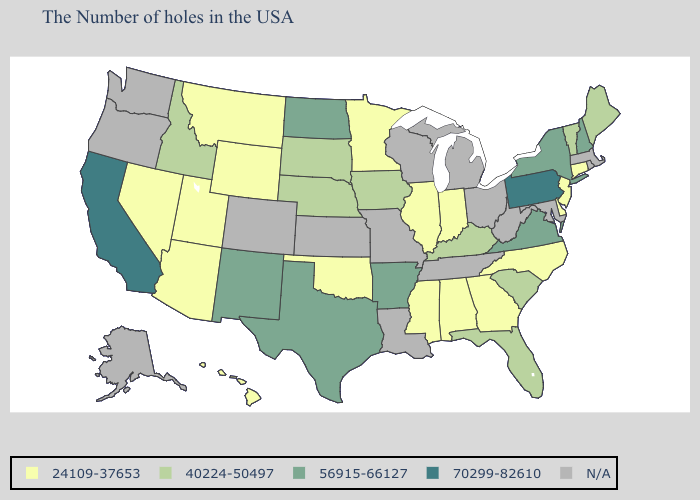What is the lowest value in the USA?
Quick response, please. 24109-37653. Name the states that have a value in the range 56915-66127?
Give a very brief answer. New Hampshire, New York, Virginia, Arkansas, Texas, North Dakota, New Mexico. Name the states that have a value in the range 56915-66127?
Concise answer only. New Hampshire, New York, Virginia, Arkansas, Texas, North Dakota, New Mexico. What is the value of Delaware?
Give a very brief answer. 24109-37653. Among the states that border Nebraska , does Wyoming have the lowest value?
Be succinct. Yes. What is the value of Maryland?
Concise answer only. N/A. What is the value of Iowa?
Keep it brief. 40224-50497. Does Virginia have the highest value in the South?
Be succinct. Yes. What is the value of Virginia?
Short answer required. 56915-66127. Name the states that have a value in the range 24109-37653?
Be succinct. Connecticut, New Jersey, Delaware, North Carolina, Georgia, Indiana, Alabama, Illinois, Mississippi, Minnesota, Oklahoma, Wyoming, Utah, Montana, Arizona, Nevada, Hawaii. Name the states that have a value in the range 24109-37653?
Be succinct. Connecticut, New Jersey, Delaware, North Carolina, Georgia, Indiana, Alabama, Illinois, Mississippi, Minnesota, Oklahoma, Wyoming, Utah, Montana, Arizona, Nevada, Hawaii. Name the states that have a value in the range 24109-37653?
Write a very short answer. Connecticut, New Jersey, Delaware, North Carolina, Georgia, Indiana, Alabama, Illinois, Mississippi, Minnesota, Oklahoma, Wyoming, Utah, Montana, Arizona, Nevada, Hawaii. Name the states that have a value in the range 40224-50497?
Short answer required. Maine, Vermont, South Carolina, Florida, Kentucky, Iowa, Nebraska, South Dakota, Idaho. Which states hav the highest value in the West?
Answer briefly. California. Name the states that have a value in the range N/A?
Keep it brief. Massachusetts, Rhode Island, Maryland, West Virginia, Ohio, Michigan, Tennessee, Wisconsin, Louisiana, Missouri, Kansas, Colorado, Washington, Oregon, Alaska. 